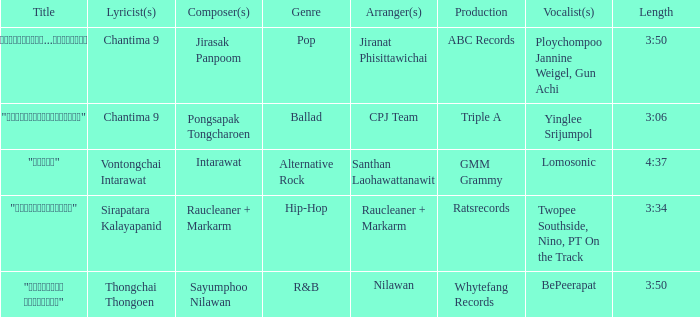Who created the composition "ขอโทษ"? Intarawat. 